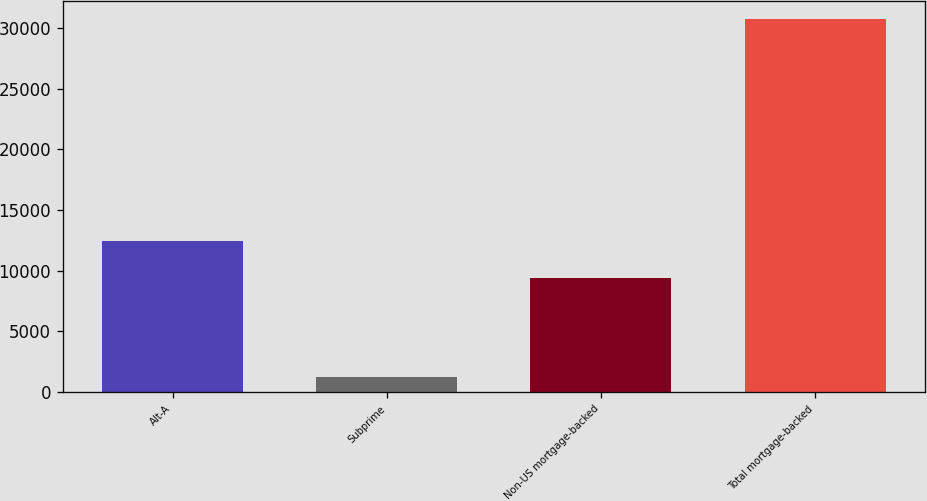Convert chart. <chart><loc_0><loc_0><loc_500><loc_500><bar_chart><fcel>Alt-A<fcel>Subprime<fcel>Non-US mortgage-backed<fcel>Total mortgage-backed<nl><fcel>12442<fcel>1243<fcel>9368<fcel>30738<nl></chart> 